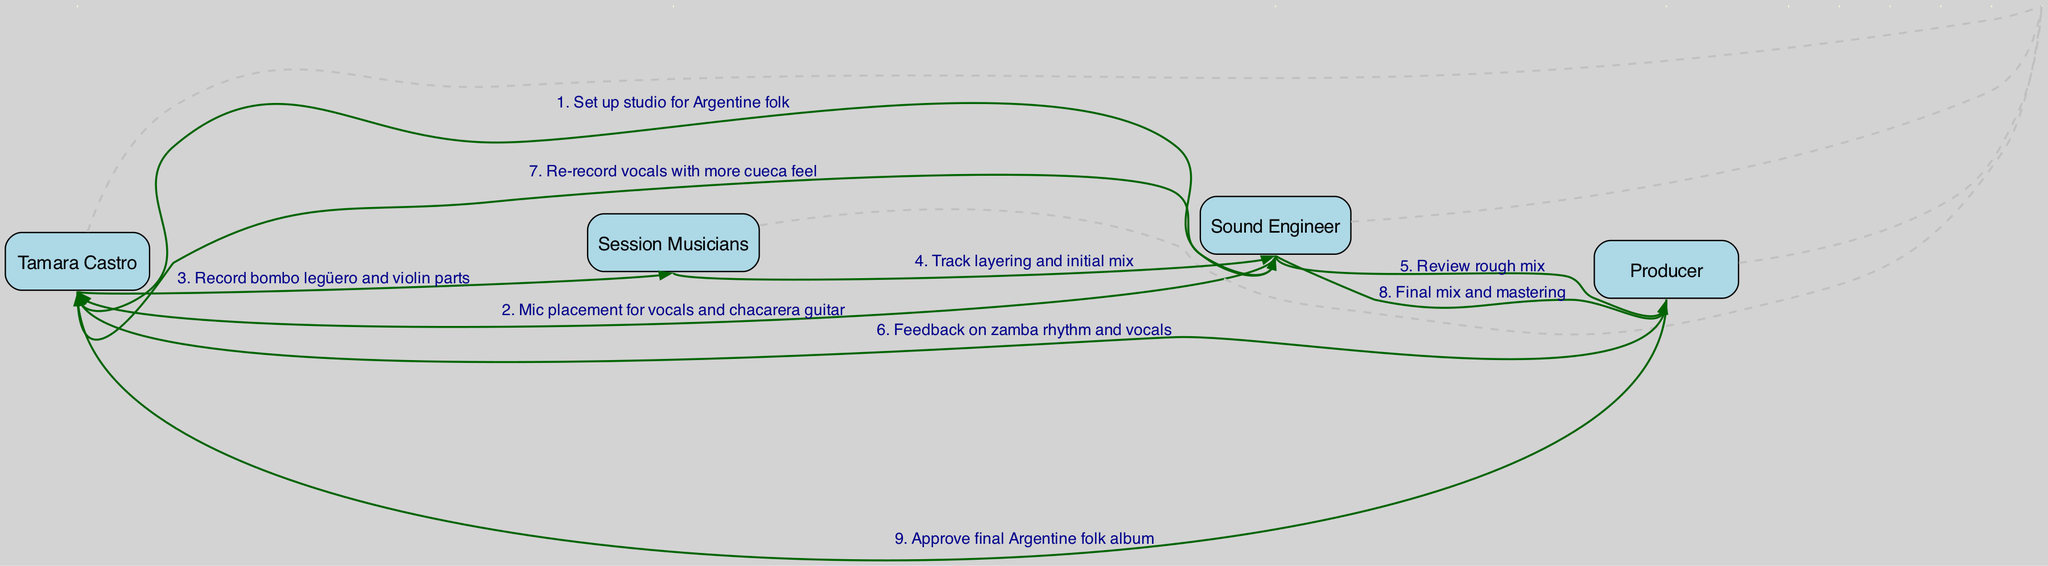What is the first action in the sequence? The first action in the sequence is "Set up studio for Argentine folk," performed by Tamara Castro.
Answer: Set up studio for Argentine folk How many actors are involved in the recording process? The diagram lists four actors involved: Tamara Castro, Sound Engineer, Session Musicians, and Producer.
Answer: Four Who provides feedback on the zamba rhythm and vocals? The Producer is the one who provides feedback on the zamba rhythm and vocals to Tamara Castro.
Answer: Producer What specific part does Tamara Castro record after setting up the studio? After setting up the studio, Tamara Castro records the bombo legüero and violin parts.
Answer: Bombo legüero and violin parts Which actor is involved in both the tracking and mixing stages? The Sound Engineer is involved in both the tracking of the session musicians and the final mixing and mastering stages.
Answer: Sound Engineer What is the action that follows the review of the rough mix? After the review of the rough mix, the action that follows is feedback on the zamba rhythm and vocals.
Answer: Feedback on zamba rhythm and vocals What is the last action performed in the sequence? The last action in the sequence is the approval of the final Argentine folk album by the Producer.
Answer: Approve final Argentine folk album How many sequential steps are outlined in the diagram? There are a total of eight sequential steps outlined in the diagram.
Answer: Eight What is the purpose of the edges between the actors? The edges between the actors represent the actions or communications that take place between them throughout the recording process.
Answer: Actions or communications What role does the Producer play in the mastering phase? The Producer is responsible for the final mix and mastering of the album as indicated in the sequence.
Answer: Final mix and mastering 